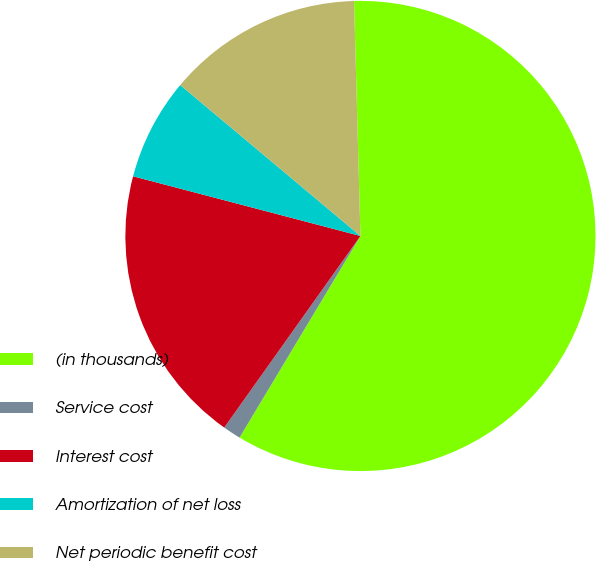<chart> <loc_0><loc_0><loc_500><loc_500><pie_chart><fcel>(in thousands)<fcel>Service cost<fcel>Interest cost<fcel>Amortization of net loss<fcel>Net periodic benefit cost<nl><fcel>59.03%<fcel>1.24%<fcel>19.25%<fcel>7.01%<fcel>13.47%<nl></chart> 